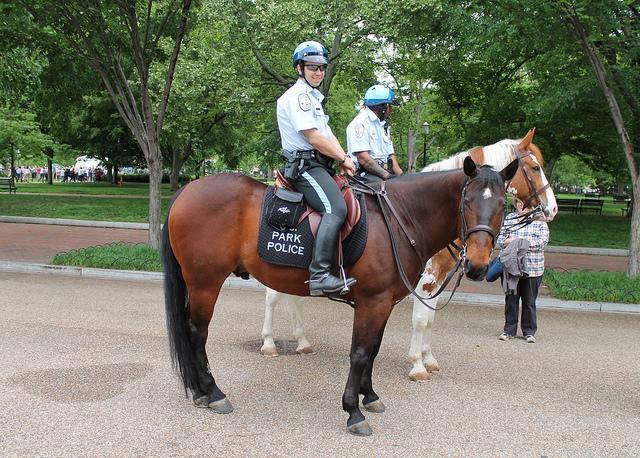How many people can be seen?
Give a very brief answer. 3. How many horses are there?
Give a very brief answer. 2. 